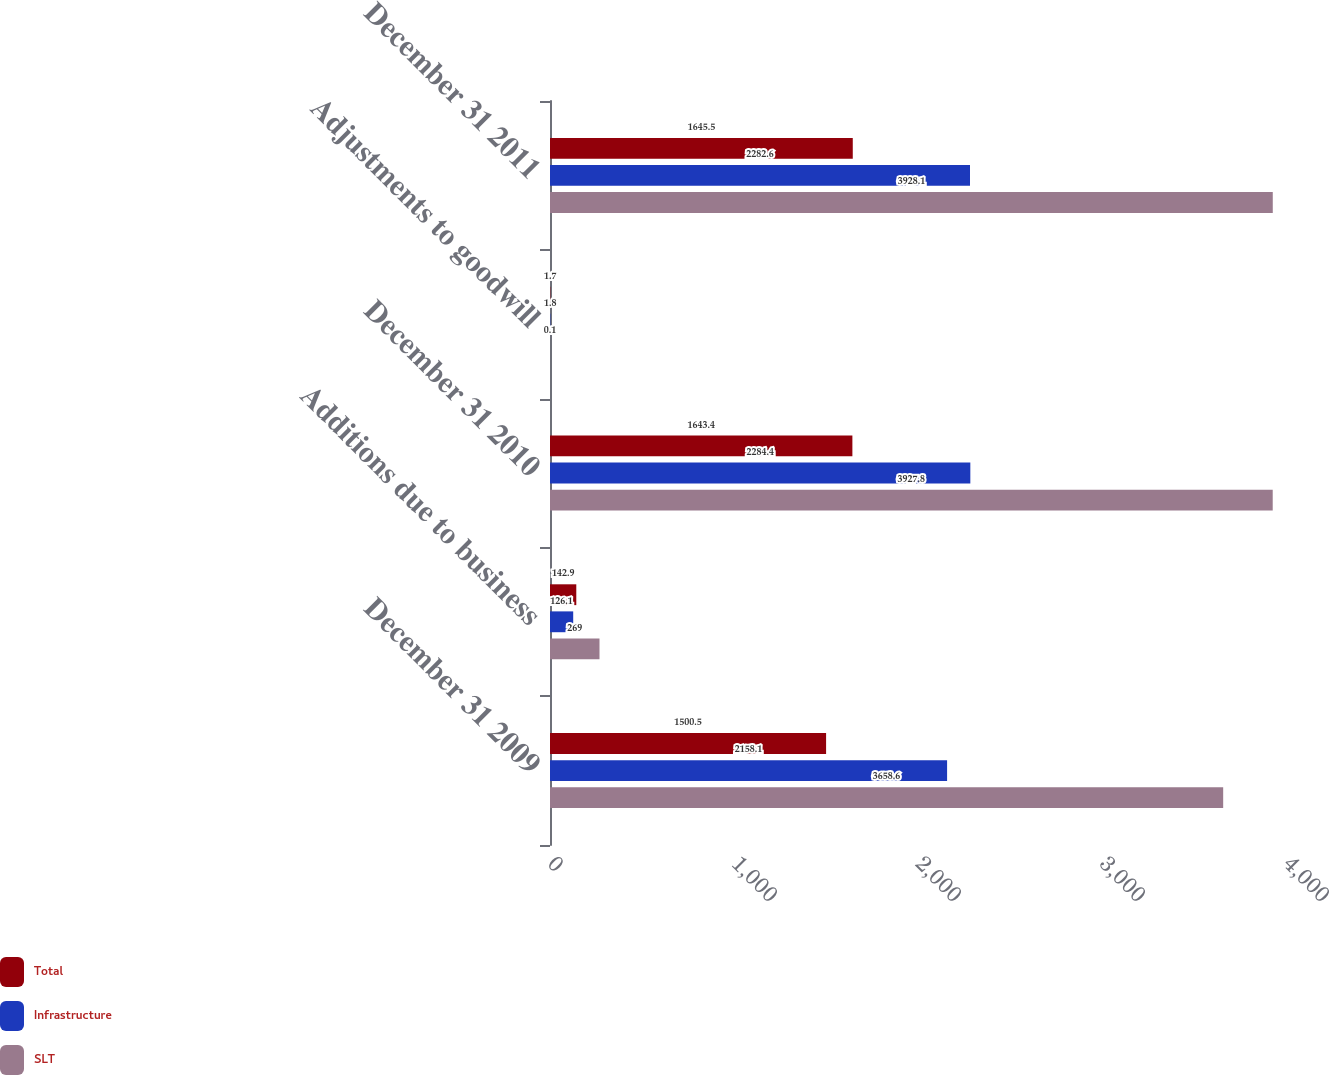Convert chart. <chart><loc_0><loc_0><loc_500><loc_500><stacked_bar_chart><ecel><fcel>December 31 2009<fcel>Additions due to business<fcel>December 31 2010<fcel>Adjustments to goodwill<fcel>December 31 2011<nl><fcel>Total<fcel>1500.5<fcel>142.9<fcel>1643.4<fcel>1.7<fcel>1645.5<nl><fcel>Infrastructure<fcel>2158.1<fcel>126.1<fcel>2284.4<fcel>1.8<fcel>2282.6<nl><fcel>SLT<fcel>3658.6<fcel>269<fcel>3927.8<fcel>0.1<fcel>3928.1<nl></chart> 